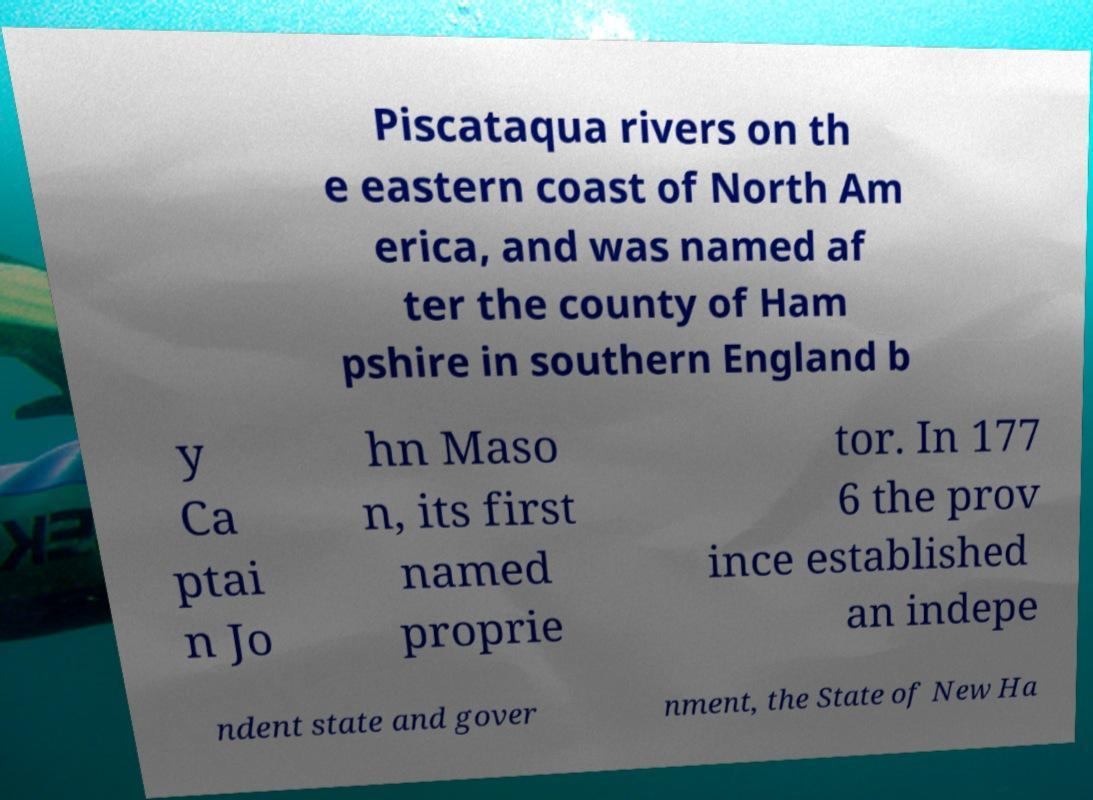Could you extract and type out the text from this image? Piscataqua rivers on th e eastern coast of North Am erica, and was named af ter the county of Ham pshire in southern England b y Ca ptai n Jo hn Maso n, its first named proprie tor. In 177 6 the prov ince established an indepe ndent state and gover nment, the State of New Ha 